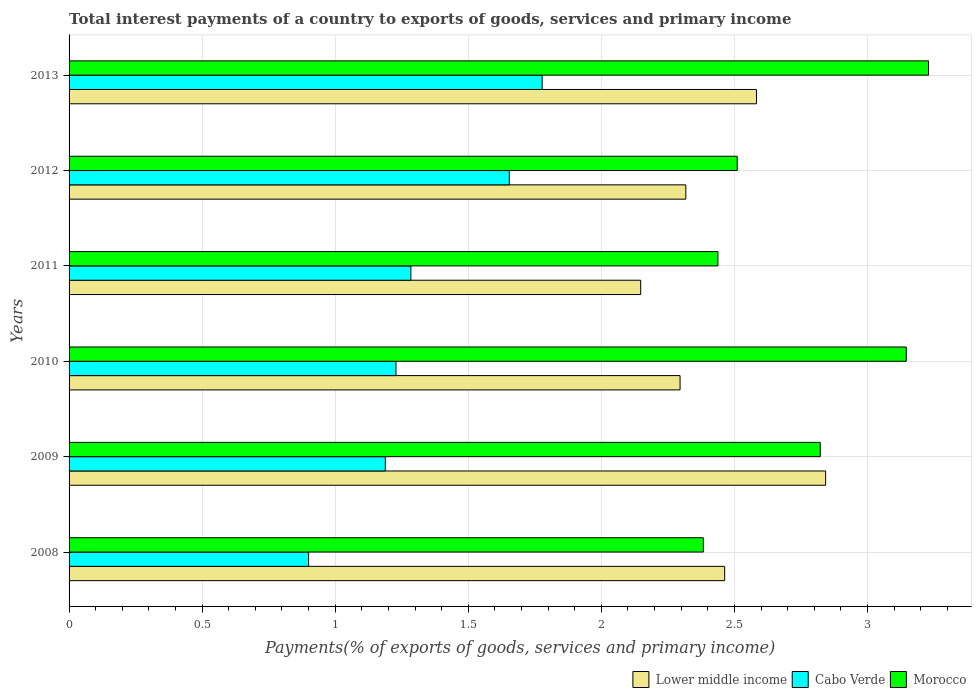Are the number of bars per tick equal to the number of legend labels?
Your response must be concise. Yes. How many bars are there on the 5th tick from the bottom?
Make the answer very short. 3. What is the total interest payments in Cabo Verde in 2011?
Keep it short and to the point. 1.28. Across all years, what is the maximum total interest payments in Cabo Verde?
Provide a short and direct response. 1.78. Across all years, what is the minimum total interest payments in Cabo Verde?
Offer a terse response. 0.9. In which year was the total interest payments in Morocco maximum?
Keep it short and to the point. 2013. In which year was the total interest payments in Cabo Verde minimum?
Make the answer very short. 2008. What is the total total interest payments in Lower middle income in the graph?
Your response must be concise. 14.65. What is the difference between the total interest payments in Cabo Verde in 2009 and that in 2012?
Offer a terse response. -0.47. What is the difference between the total interest payments in Morocco in 2009 and the total interest payments in Cabo Verde in 2012?
Provide a succinct answer. 1.17. What is the average total interest payments in Lower middle income per year?
Offer a very short reply. 2.44. In the year 2008, what is the difference between the total interest payments in Lower middle income and total interest payments in Cabo Verde?
Make the answer very short. 1.56. What is the ratio of the total interest payments in Cabo Verde in 2008 to that in 2012?
Provide a short and direct response. 0.54. What is the difference between the highest and the second highest total interest payments in Lower middle income?
Provide a succinct answer. 0.26. What is the difference between the highest and the lowest total interest payments in Morocco?
Your response must be concise. 0.85. Is the sum of the total interest payments in Lower middle income in 2009 and 2013 greater than the maximum total interest payments in Cabo Verde across all years?
Offer a very short reply. Yes. What does the 1st bar from the top in 2013 represents?
Give a very brief answer. Morocco. What does the 3rd bar from the bottom in 2008 represents?
Your answer should be compact. Morocco. Is it the case that in every year, the sum of the total interest payments in Lower middle income and total interest payments in Morocco is greater than the total interest payments in Cabo Verde?
Ensure brevity in your answer.  Yes. How many bars are there?
Provide a short and direct response. 18. Are all the bars in the graph horizontal?
Provide a succinct answer. Yes. Does the graph contain any zero values?
Your answer should be compact. No. Does the graph contain grids?
Offer a terse response. Yes. Where does the legend appear in the graph?
Provide a succinct answer. Bottom right. How are the legend labels stacked?
Keep it short and to the point. Horizontal. What is the title of the graph?
Your response must be concise. Total interest payments of a country to exports of goods, services and primary income. What is the label or title of the X-axis?
Offer a very short reply. Payments(% of exports of goods, services and primary income). What is the Payments(% of exports of goods, services and primary income) of Lower middle income in 2008?
Make the answer very short. 2.46. What is the Payments(% of exports of goods, services and primary income) of Cabo Verde in 2008?
Ensure brevity in your answer.  0.9. What is the Payments(% of exports of goods, services and primary income) of Morocco in 2008?
Provide a short and direct response. 2.38. What is the Payments(% of exports of goods, services and primary income) in Lower middle income in 2009?
Keep it short and to the point. 2.84. What is the Payments(% of exports of goods, services and primary income) in Cabo Verde in 2009?
Provide a short and direct response. 1.19. What is the Payments(% of exports of goods, services and primary income) in Morocco in 2009?
Offer a terse response. 2.82. What is the Payments(% of exports of goods, services and primary income) in Lower middle income in 2010?
Provide a succinct answer. 2.3. What is the Payments(% of exports of goods, services and primary income) of Cabo Verde in 2010?
Offer a terse response. 1.23. What is the Payments(% of exports of goods, services and primary income) of Morocco in 2010?
Your answer should be compact. 3.15. What is the Payments(% of exports of goods, services and primary income) in Lower middle income in 2011?
Offer a terse response. 2.15. What is the Payments(% of exports of goods, services and primary income) in Cabo Verde in 2011?
Provide a succinct answer. 1.28. What is the Payments(% of exports of goods, services and primary income) of Morocco in 2011?
Your response must be concise. 2.44. What is the Payments(% of exports of goods, services and primary income) in Lower middle income in 2012?
Provide a succinct answer. 2.32. What is the Payments(% of exports of goods, services and primary income) in Cabo Verde in 2012?
Provide a succinct answer. 1.65. What is the Payments(% of exports of goods, services and primary income) in Morocco in 2012?
Your answer should be very brief. 2.51. What is the Payments(% of exports of goods, services and primary income) in Lower middle income in 2013?
Give a very brief answer. 2.58. What is the Payments(% of exports of goods, services and primary income) in Cabo Verde in 2013?
Provide a succinct answer. 1.78. What is the Payments(% of exports of goods, services and primary income) of Morocco in 2013?
Provide a short and direct response. 3.23. Across all years, what is the maximum Payments(% of exports of goods, services and primary income) in Lower middle income?
Give a very brief answer. 2.84. Across all years, what is the maximum Payments(% of exports of goods, services and primary income) of Cabo Verde?
Ensure brevity in your answer.  1.78. Across all years, what is the maximum Payments(% of exports of goods, services and primary income) in Morocco?
Provide a succinct answer. 3.23. Across all years, what is the minimum Payments(% of exports of goods, services and primary income) of Lower middle income?
Offer a very short reply. 2.15. Across all years, what is the minimum Payments(% of exports of goods, services and primary income) of Cabo Verde?
Provide a succinct answer. 0.9. Across all years, what is the minimum Payments(% of exports of goods, services and primary income) of Morocco?
Give a very brief answer. 2.38. What is the total Payments(% of exports of goods, services and primary income) of Lower middle income in the graph?
Your answer should be very brief. 14.65. What is the total Payments(% of exports of goods, services and primary income) in Cabo Verde in the graph?
Your response must be concise. 8.03. What is the total Payments(% of exports of goods, services and primary income) in Morocco in the graph?
Your answer should be very brief. 16.53. What is the difference between the Payments(% of exports of goods, services and primary income) in Lower middle income in 2008 and that in 2009?
Keep it short and to the point. -0.38. What is the difference between the Payments(% of exports of goods, services and primary income) of Cabo Verde in 2008 and that in 2009?
Your response must be concise. -0.29. What is the difference between the Payments(% of exports of goods, services and primary income) of Morocco in 2008 and that in 2009?
Make the answer very short. -0.44. What is the difference between the Payments(% of exports of goods, services and primary income) in Lower middle income in 2008 and that in 2010?
Give a very brief answer. 0.17. What is the difference between the Payments(% of exports of goods, services and primary income) of Cabo Verde in 2008 and that in 2010?
Provide a short and direct response. -0.33. What is the difference between the Payments(% of exports of goods, services and primary income) in Morocco in 2008 and that in 2010?
Make the answer very short. -0.76. What is the difference between the Payments(% of exports of goods, services and primary income) in Lower middle income in 2008 and that in 2011?
Your response must be concise. 0.32. What is the difference between the Payments(% of exports of goods, services and primary income) of Cabo Verde in 2008 and that in 2011?
Offer a terse response. -0.38. What is the difference between the Payments(% of exports of goods, services and primary income) in Morocco in 2008 and that in 2011?
Ensure brevity in your answer.  -0.05. What is the difference between the Payments(% of exports of goods, services and primary income) in Lower middle income in 2008 and that in 2012?
Your response must be concise. 0.15. What is the difference between the Payments(% of exports of goods, services and primary income) in Cabo Verde in 2008 and that in 2012?
Ensure brevity in your answer.  -0.75. What is the difference between the Payments(% of exports of goods, services and primary income) of Morocco in 2008 and that in 2012?
Give a very brief answer. -0.13. What is the difference between the Payments(% of exports of goods, services and primary income) of Lower middle income in 2008 and that in 2013?
Offer a very short reply. -0.12. What is the difference between the Payments(% of exports of goods, services and primary income) in Cabo Verde in 2008 and that in 2013?
Keep it short and to the point. -0.88. What is the difference between the Payments(% of exports of goods, services and primary income) of Morocco in 2008 and that in 2013?
Offer a very short reply. -0.85. What is the difference between the Payments(% of exports of goods, services and primary income) in Lower middle income in 2009 and that in 2010?
Offer a terse response. 0.55. What is the difference between the Payments(% of exports of goods, services and primary income) in Cabo Verde in 2009 and that in 2010?
Your answer should be very brief. -0.04. What is the difference between the Payments(% of exports of goods, services and primary income) in Morocco in 2009 and that in 2010?
Provide a succinct answer. -0.32. What is the difference between the Payments(% of exports of goods, services and primary income) in Lower middle income in 2009 and that in 2011?
Provide a succinct answer. 0.69. What is the difference between the Payments(% of exports of goods, services and primary income) in Cabo Verde in 2009 and that in 2011?
Ensure brevity in your answer.  -0.1. What is the difference between the Payments(% of exports of goods, services and primary income) of Morocco in 2009 and that in 2011?
Your response must be concise. 0.38. What is the difference between the Payments(% of exports of goods, services and primary income) in Lower middle income in 2009 and that in 2012?
Your answer should be very brief. 0.53. What is the difference between the Payments(% of exports of goods, services and primary income) of Cabo Verde in 2009 and that in 2012?
Offer a very short reply. -0.47. What is the difference between the Payments(% of exports of goods, services and primary income) of Morocco in 2009 and that in 2012?
Make the answer very short. 0.31. What is the difference between the Payments(% of exports of goods, services and primary income) of Lower middle income in 2009 and that in 2013?
Provide a short and direct response. 0.26. What is the difference between the Payments(% of exports of goods, services and primary income) of Cabo Verde in 2009 and that in 2013?
Offer a very short reply. -0.59. What is the difference between the Payments(% of exports of goods, services and primary income) of Morocco in 2009 and that in 2013?
Your response must be concise. -0.41. What is the difference between the Payments(% of exports of goods, services and primary income) in Lower middle income in 2010 and that in 2011?
Keep it short and to the point. 0.15. What is the difference between the Payments(% of exports of goods, services and primary income) in Cabo Verde in 2010 and that in 2011?
Offer a very short reply. -0.06. What is the difference between the Payments(% of exports of goods, services and primary income) of Morocco in 2010 and that in 2011?
Your answer should be very brief. 0.71. What is the difference between the Payments(% of exports of goods, services and primary income) of Lower middle income in 2010 and that in 2012?
Offer a very short reply. -0.02. What is the difference between the Payments(% of exports of goods, services and primary income) of Cabo Verde in 2010 and that in 2012?
Offer a very short reply. -0.43. What is the difference between the Payments(% of exports of goods, services and primary income) of Morocco in 2010 and that in 2012?
Keep it short and to the point. 0.64. What is the difference between the Payments(% of exports of goods, services and primary income) of Lower middle income in 2010 and that in 2013?
Your response must be concise. -0.29. What is the difference between the Payments(% of exports of goods, services and primary income) in Cabo Verde in 2010 and that in 2013?
Offer a terse response. -0.55. What is the difference between the Payments(% of exports of goods, services and primary income) of Morocco in 2010 and that in 2013?
Give a very brief answer. -0.08. What is the difference between the Payments(% of exports of goods, services and primary income) of Lower middle income in 2011 and that in 2012?
Ensure brevity in your answer.  -0.17. What is the difference between the Payments(% of exports of goods, services and primary income) in Cabo Verde in 2011 and that in 2012?
Ensure brevity in your answer.  -0.37. What is the difference between the Payments(% of exports of goods, services and primary income) in Morocco in 2011 and that in 2012?
Offer a very short reply. -0.07. What is the difference between the Payments(% of exports of goods, services and primary income) of Lower middle income in 2011 and that in 2013?
Your response must be concise. -0.44. What is the difference between the Payments(% of exports of goods, services and primary income) in Cabo Verde in 2011 and that in 2013?
Make the answer very short. -0.49. What is the difference between the Payments(% of exports of goods, services and primary income) of Morocco in 2011 and that in 2013?
Make the answer very short. -0.79. What is the difference between the Payments(% of exports of goods, services and primary income) in Lower middle income in 2012 and that in 2013?
Offer a very short reply. -0.27. What is the difference between the Payments(% of exports of goods, services and primary income) in Cabo Verde in 2012 and that in 2013?
Provide a short and direct response. -0.12. What is the difference between the Payments(% of exports of goods, services and primary income) of Morocco in 2012 and that in 2013?
Provide a succinct answer. -0.72. What is the difference between the Payments(% of exports of goods, services and primary income) in Lower middle income in 2008 and the Payments(% of exports of goods, services and primary income) in Cabo Verde in 2009?
Ensure brevity in your answer.  1.28. What is the difference between the Payments(% of exports of goods, services and primary income) of Lower middle income in 2008 and the Payments(% of exports of goods, services and primary income) of Morocco in 2009?
Provide a succinct answer. -0.36. What is the difference between the Payments(% of exports of goods, services and primary income) in Cabo Verde in 2008 and the Payments(% of exports of goods, services and primary income) in Morocco in 2009?
Give a very brief answer. -1.92. What is the difference between the Payments(% of exports of goods, services and primary income) in Lower middle income in 2008 and the Payments(% of exports of goods, services and primary income) in Cabo Verde in 2010?
Your response must be concise. 1.24. What is the difference between the Payments(% of exports of goods, services and primary income) of Lower middle income in 2008 and the Payments(% of exports of goods, services and primary income) of Morocco in 2010?
Your response must be concise. -0.68. What is the difference between the Payments(% of exports of goods, services and primary income) of Cabo Verde in 2008 and the Payments(% of exports of goods, services and primary income) of Morocco in 2010?
Give a very brief answer. -2.25. What is the difference between the Payments(% of exports of goods, services and primary income) of Lower middle income in 2008 and the Payments(% of exports of goods, services and primary income) of Cabo Verde in 2011?
Offer a very short reply. 1.18. What is the difference between the Payments(% of exports of goods, services and primary income) of Lower middle income in 2008 and the Payments(% of exports of goods, services and primary income) of Morocco in 2011?
Your answer should be compact. 0.03. What is the difference between the Payments(% of exports of goods, services and primary income) of Cabo Verde in 2008 and the Payments(% of exports of goods, services and primary income) of Morocco in 2011?
Provide a short and direct response. -1.54. What is the difference between the Payments(% of exports of goods, services and primary income) in Lower middle income in 2008 and the Payments(% of exports of goods, services and primary income) in Cabo Verde in 2012?
Provide a succinct answer. 0.81. What is the difference between the Payments(% of exports of goods, services and primary income) in Lower middle income in 2008 and the Payments(% of exports of goods, services and primary income) in Morocco in 2012?
Ensure brevity in your answer.  -0.05. What is the difference between the Payments(% of exports of goods, services and primary income) of Cabo Verde in 2008 and the Payments(% of exports of goods, services and primary income) of Morocco in 2012?
Offer a very short reply. -1.61. What is the difference between the Payments(% of exports of goods, services and primary income) in Lower middle income in 2008 and the Payments(% of exports of goods, services and primary income) in Cabo Verde in 2013?
Your answer should be very brief. 0.69. What is the difference between the Payments(% of exports of goods, services and primary income) in Lower middle income in 2008 and the Payments(% of exports of goods, services and primary income) in Morocco in 2013?
Keep it short and to the point. -0.77. What is the difference between the Payments(% of exports of goods, services and primary income) of Cabo Verde in 2008 and the Payments(% of exports of goods, services and primary income) of Morocco in 2013?
Your answer should be very brief. -2.33. What is the difference between the Payments(% of exports of goods, services and primary income) in Lower middle income in 2009 and the Payments(% of exports of goods, services and primary income) in Cabo Verde in 2010?
Ensure brevity in your answer.  1.61. What is the difference between the Payments(% of exports of goods, services and primary income) of Lower middle income in 2009 and the Payments(% of exports of goods, services and primary income) of Morocco in 2010?
Make the answer very short. -0.3. What is the difference between the Payments(% of exports of goods, services and primary income) of Cabo Verde in 2009 and the Payments(% of exports of goods, services and primary income) of Morocco in 2010?
Your response must be concise. -1.96. What is the difference between the Payments(% of exports of goods, services and primary income) in Lower middle income in 2009 and the Payments(% of exports of goods, services and primary income) in Cabo Verde in 2011?
Provide a succinct answer. 1.56. What is the difference between the Payments(% of exports of goods, services and primary income) of Lower middle income in 2009 and the Payments(% of exports of goods, services and primary income) of Morocco in 2011?
Your response must be concise. 0.4. What is the difference between the Payments(% of exports of goods, services and primary income) in Cabo Verde in 2009 and the Payments(% of exports of goods, services and primary income) in Morocco in 2011?
Your answer should be very brief. -1.25. What is the difference between the Payments(% of exports of goods, services and primary income) in Lower middle income in 2009 and the Payments(% of exports of goods, services and primary income) in Cabo Verde in 2012?
Ensure brevity in your answer.  1.19. What is the difference between the Payments(% of exports of goods, services and primary income) of Lower middle income in 2009 and the Payments(% of exports of goods, services and primary income) of Morocco in 2012?
Your answer should be compact. 0.33. What is the difference between the Payments(% of exports of goods, services and primary income) in Cabo Verde in 2009 and the Payments(% of exports of goods, services and primary income) in Morocco in 2012?
Give a very brief answer. -1.32. What is the difference between the Payments(% of exports of goods, services and primary income) of Lower middle income in 2009 and the Payments(% of exports of goods, services and primary income) of Cabo Verde in 2013?
Provide a short and direct response. 1.07. What is the difference between the Payments(% of exports of goods, services and primary income) in Lower middle income in 2009 and the Payments(% of exports of goods, services and primary income) in Morocco in 2013?
Your answer should be very brief. -0.39. What is the difference between the Payments(% of exports of goods, services and primary income) of Cabo Verde in 2009 and the Payments(% of exports of goods, services and primary income) of Morocco in 2013?
Make the answer very short. -2.04. What is the difference between the Payments(% of exports of goods, services and primary income) of Lower middle income in 2010 and the Payments(% of exports of goods, services and primary income) of Cabo Verde in 2011?
Keep it short and to the point. 1.01. What is the difference between the Payments(% of exports of goods, services and primary income) in Lower middle income in 2010 and the Payments(% of exports of goods, services and primary income) in Morocco in 2011?
Your answer should be very brief. -0.14. What is the difference between the Payments(% of exports of goods, services and primary income) in Cabo Verde in 2010 and the Payments(% of exports of goods, services and primary income) in Morocco in 2011?
Keep it short and to the point. -1.21. What is the difference between the Payments(% of exports of goods, services and primary income) of Lower middle income in 2010 and the Payments(% of exports of goods, services and primary income) of Cabo Verde in 2012?
Ensure brevity in your answer.  0.64. What is the difference between the Payments(% of exports of goods, services and primary income) in Lower middle income in 2010 and the Payments(% of exports of goods, services and primary income) in Morocco in 2012?
Your response must be concise. -0.21. What is the difference between the Payments(% of exports of goods, services and primary income) of Cabo Verde in 2010 and the Payments(% of exports of goods, services and primary income) of Morocco in 2012?
Provide a succinct answer. -1.28. What is the difference between the Payments(% of exports of goods, services and primary income) of Lower middle income in 2010 and the Payments(% of exports of goods, services and primary income) of Cabo Verde in 2013?
Provide a short and direct response. 0.52. What is the difference between the Payments(% of exports of goods, services and primary income) of Lower middle income in 2010 and the Payments(% of exports of goods, services and primary income) of Morocco in 2013?
Ensure brevity in your answer.  -0.93. What is the difference between the Payments(% of exports of goods, services and primary income) in Cabo Verde in 2010 and the Payments(% of exports of goods, services and primary income) in Morocco in 2013?
Make the answer very short. -2. What is the difference between the Payments(% of exports of goods, services and primary income) of Lower middle income in 2011 and the Payments(% of exports of goods, services and primary income) of Cabo Verde in 2012?
Provide a succinct answer. 0.49. What is the difference between the Payments(% of exports of goods, services and primary income) in Lower middle income in 2011 and the Payments(% of exports of goods, services and primary income) in Morocco in 2012?
Give a very brief answer. -0.36. What is the difference between the Payments(% of exports of goods, services and primary income) in Cabo Verde in 2011 and the Payments(% of exports of goods, services and primary income) in Morocco in 2012?
Provide a short and direct response. -1.23. What is the difference between the Payments(% of exports of goods, services and primary income) of Lower middle income in 2011 and the Payments(% of exports of goods, services and primary income) of Cabo Verde in 2013?
Keep it short and to the point. 0.37. What is the difference between the Payments(% of exports of goods, services and primary income) in Lower middle income in 2011 and the Payments(% of exports of goods, services and primary income) in Morocco in 2013?
Provide a short and direct response. -1.08. What is the difference between the Payments(% of exports of goods, services and primary income) in Cabo Verde in 2011 and the Payments(% of exports of goods, services and primary income) in Morocco in 2013?
Your answer should be very brief. -1.95. What is the difference between the Payments(% of exports of goods, services and primary income) in Lower middle income in 2012 and the Payments(% of exports of goods, services and primary income) in Cabo Verde in 2013?
Offer a very short reply. 0.54. What is the difference between the Payments(% of exports of goods, services and primary income) in Lower middle income in 2012 and the Payments(% of exports of goods, services and primary income) in Morocco in 2013?
Your answer should be compact. -0.91. What is the difference between the Payments(% of exports of goods, services and primary income) in Cabo Verde in 2012 and the Payments(% of exports of goods, services and primary income) in Morocco in 2013?
Your answer should be compact. -1.58. What is the average Payments(% of exports of goods, services and primary income) of Lower middle income per year?
Your response must be concise. 2.44. What is the average Payments(% of exports of goods, services and primary income) of Cabo Verde per year?
Your answer should be compact. 1.34. What is the average Payments(% of exports of goods, services and primary income) of Morocco per year?
Your answer should be very brief. 2.75. In the year 2008, what is the difference between the Payments(% of exports of goods, services and primary income) of Lower middle income and Payments(% of exports of goods, services and primary income) of Cabo Verde?
Provide a succinct answer. 1.56. In the year 2008, what is the difference between the Payments(% of exports of goods, services and primary income) of Lower middle income and Payments(% of exports of goods, services and primary income) of Morocco?
Give a very brief answer. 0.08. In the year 2008, what is the difference between the Payments(% of exports of goods, services and primary income) of Cabo Verde and Payments(% of exports of goods, services and primary income) of Morocco?
Your response must be concise. -1.48. In the year 2009, what is the difference between the Payments(% of exports of goods, services and primary income) in Lower middle income and Payments(% of exports of goods, services and primary income) in Cabo Verde?
Offer a very short reply. 1.65. In the year 2009, what is the difference between the Payments(% of exports of goods, services and primary income) in Lower middle income and Payments(% of exports of goods, services and primary income) in Morocco?
Your response must be concise. 0.02. In the year 2009, what is the difference between the Payments(% of exports of goods, services and primary income) of Cabo Verde and Payments(% of exports of goods, services and primary income) of Morocco?
Ensure brevity in your answer.  -1.63. In the year 2010, what is the difference between the Payments(% of exports of goods, services and primary income) of Lower middle income and Payments(% of exports of goods, services and primary income) of Cabo Verde?
Provide a succinct answer. 1.07. In the year 2010, what is the difference between the Payments(% of exports of goods, services and primary income) in Lower middle income and Payments(% of exports of goods, services and primary income) in Morocco?
Make the answer very short. -0.85. In the year 2010, what is the difference between the Payments(% of exports of goods, services and primary income) in Cabo Verde and Payments(% of exports of goods, services and primary income) in Morocco?
Your response must be concise. -1.92. In the year 2011, what is the difference between the Payments(% of exports of goods, services and primary income) in Lower middle income and Payments(% of exports of goods, services and primary income) in Cabo Verde?
Your answer should be very brief. 0.86. In the year 2011, what is the difference between the Payments(% of exports of goods, services and primary income) of Lower middle income and Payments(% of exports of goods, services and primary income) of Morocco?
Ensure brevity in your answer.  -0.29. In the year 2011, what is the difference between the Payments(% of exports of goods, services and primary income) of Cabo Verde and Payments(% of exports of goods, services and primary income) of Morocco?
Ensure brevity in your answer.  -1.15. In the year 2012, what is the difference between the Payments(% of exports of goods, services and primary income) in Lower middle income and Payments(% of exports of goods, services and primary income) in Cabo Verde?
Make the answer very short. 0.66. In the year 2012, what is the difference between the Payments(% of exports of goods, services and primary income) in Lower middle income and Payments(% of exports of goods, services and primary income) in Morocco?
Your answer should be very brief. -0.19. In the year 2012, what is the difference between the Payments(% of exports of goods, services and primary income) in Cabo Verde and Payments(% of exports of goods, services and primary income) in Morocco?
Ensure brevity in your answer.  -0.86. In the year 2013, what is the difference between the Payments(% of exports of goods, services and primary income) of Lower middle income and Payments(% of exports of goods, services and primary income) of Cabo Verde?
Provide a succinct answer. 0.81. In the year 2013, what is the difference between the Payments(% of exports of goods, services and primary income) in Lower middle income and Payments(% of exports of goods, services and primary income) in Morocco?
Provide a succinct answer. -0.65. In the year 2013, what is the difference between the Payments(% of exports of goods, services and primary income) of Cabo Verde and Payments(% of exports of goods, services and primary income) of Morocco?
Offer a terse response. -1.45. What is the ratio of the Payments(% of exports of goods, services and primary income) of Lower middle income in 2008 to that in 2009?
Ensure brevity in your answer.  0.87. What is the ratio of the Payments(% of exports of goods, services and primary income) of Cabo Verde in 2008 to that in 2009?
Your answer should be very brief. 0.76. What is the ratio of the Payments(% of exports of goods, services and primary income) in Morocco in 2008 to that in 2009?
Give a very brief answer. 0.84. What is the ratio of the Payments(% of exports of goods, services and primary income) of Lower middle income in 2008 to that in 2010?
Your response must be concise. 1.07. What is the ratio of the Payments(% of exports of goods, services and primary income) in Cabo Verde in 2008 to that in 2010?
Your answer should be very brief. 0.73. What is the ratio of the Payments(% of exports of goods, services and primary income) in Morocco in 2008 to that in 2010?
Offer a terse response. 0.76. What is the ratio of the Payments(% of exports of goods, services and primary income) in Lower middle income in 2008 to that in 2011?
Offer a terse response. 1.15. What is the ratio of the Payments(% of exports of goods, services and primary income) in Cabo Verde in 2008 to that in 2011?
Provide a succinct answer. 0.7. What is the ratio of the Payments(% of exports of goods, services and primary income) in Morocco in 2008 to that in 2011?
Provide a short and direct response. 0.98. What is the ratio of the Payments(% of exports of goods, services and primary income) of Lower middle income in 2008 to that in 2012?
Offer a terse response. 1.06. What is the ratio of the Payments(% of exports of goods, services and primary income) of Cabo Verde in 2008 to that in 2012?
Provide a succinct answer. 0.54. What is the ratio of the Payments(% of exports of goods, services and primary income) in Morocco in 2008 to that in 2012?
Provide a short and direct response. 0.95. What is the ratio of the Payments(% of exports of goods, services and primary income) in Lower middle income in 2008 to that in 2013?
Give a very brief answer. 0.95. What is the ratio of the Payments(% of exports of goods, services and primary income) of Cabo Verde in 2008 to that in 2013?
Offer a terse response. 0.51. What is the ratio of the Payments(% of exports of goods, services and primary income) of Morocco in 2008 to that in 2013?
Provide a short and direct response. 0.74. What is the ratio of the Payments(% of exports of goods, services and primary income) in Lower middle income in 2009 to that in 2010?
Provide a succinct answer. 1.24. What is the ratio of the Payments(% of exports of goods, services and primary income) in Cabo Verde in 2009 to that in 2010?
Offer a very short reply. 0.97. What is the ratio of the Payments(% of exports of goods, services and primary income) of Morocco in 2009 to that in 2010?
Offer a terse response. 0.9. What is the ratio of the Payments(% of exports of goods, services and primary income) of Lower middle income in 2009 to that in 2011?
Keep it short and to the point. 1.32. What is the ratio of the Payments(% of exports of goods, services and primary income) of Cabo Verde in 2009 to that in 2011?
Give a very brief answer. 0.93. What is the ratio of the Payments(% of exports of goods, services and primary income) of Morocco in 2009 to that in 2011?
Offer a very short reply. 1.16. What is the ratio of the Payments(% of exports of goods, services and primary income) in Lower middle income in 2009 to that in 2012?
Provide a succinct answer. 1.23. What is the ratio of the Payments(% of exports of goods, services and primary income) of Cabo Verde in 2009 to that in 2012?
Your answer should be compact. 0.72. What is the ratio of the Payments(% of exports of goods, services and primary income) in Morocco in 2009 to that in 2012?
Offer a very short reply. 1.12. What is the ratio of the Payments(% of exports of goods, services and primary income) in Lower middle income in 2009 to that in 2013?
Your answer should be compact. 1.1. What is the ratio of the Payments(% of exports of goods, services and primary income) of Cabo Verde in 2009 to that in 2013?
Your response must be concise. 0.67. What is the ratio of the Payments(% of exports of goods, services and primary income) of Morocco in 2009 to that in 2013?
Make the answer very short. 0.87. What is the ratio of the Payments(% of exports of goods, services and primary income) of Lower middle income in 2010 to that in 2011?
Keep it short and to the point. 1.07. What is the ratio of the Payments(% of exports of goods, services and primary income) in Cabo Verde in 2010 to that in 2011?
Make the answer very short. 0.96. What is the ratio of the Payments(% of exports of goods, services and primary income) of Morocco in 2010 to that in 2011?
Make the answer very short. 1.29. What is the ratio of the Payments(% of exports of goods, services and primary income) of Cabo Verde in 2010 to that in 2012?
Make the answer very short. 0.74. What is the ratio of the Payments(% of exports of goods, services and primary income) in Morocco in 2010 to that in 2012?
Your response must be concise. 1.25. What is the ratio of the Payments(% of exports of goods, services and primary income) of Lower middle income in 2010 to that in 2013?
Provide a short and direct response. 0.89. What is the ratio of the Payments(% of exports of goods, services and primary income) in Cabo Verde in 2010 to that in 2013?
Your response must be concise. 0.69. What is the ratio of the Payments(% of exports of goods, services and primary income) of Morocco in 2010 to that in 2013?
Ensure brevity in your answer.  0.97. What is the ratio of the Payments(% of exports of goods, services and primary income) in Lower middle income in 2011 to that in 2012?
Offer a very short reply. 0.93. What is the ratio of the Payments(% of exports of goods, services and primary income) in Cabo Verde in 2011 to that in 2012?
Offer a terse response. 0.78. What is the ratio of the Payments(% of exports of goods, services and primary income) in Morocco in 2011 to that in 2012?
Your response must be concise. 0.97. What is the ratio of the Payments(% of exports of goods, services and primary income) in Lower middle income in 2011 to that in 2013?
Provide a succinct answer. 0.83. What is the ratio of the Payments(% of exports of goods, services and primary income) in Cabo Verde in 2011 to that in 2013?
Provide a succinct answer. 0.72. What is the ratio of the Payments(% of exports of goods, services and primary income) in Morocco in 2011 to that in 2013?
Give a very brief answer. 0.76. What is the ratio of the Payments(% of exports of goods, services and primary income) in Lower middle income in 2012 to that in 2013?
Offer a terse response. 0.9. What is the ratio of the Payments(% of exports of goods, services and primary income) in Cabo Verde in 2012 to that in 2013?
Offer a very short reply. 0.93. What is the ratio of the Payments(% of exports of goods, services and primary income) in Morocco in 2012 to that in 2013?
Keep it short and to the point. 0.78. What is the difference between the highest and the second highest Payments(% of exports of goods, services and primary income) of Lower middle income?
Your answer should be compact. 0.26. What is the difference between the highest and the second highest Payments(% of exports of goods, services and primary income) in Cabo Verde?
Your answer should be very brief. 0.12. What is the difference between the highest and the second highest Payments(% of exports of goods, services and primary income) of Morocco?
Ensure brevity in your answer.  0.08. What is the difference between the highest and the lowest Payments(% of exports of goods, services and primary income) in Lower middle income?
Keep it short and to the point. 0.69. What is the difference between the highest and the lowest Payments(% of exports of goods, services and primary income) in Cabo Verde?
Your answer should be very brief. 0.88. What is the difference between the highest and the lowest Payments(% of exports of goods, services and primary income) of Morocco?
Your answer should be very brief. 0.85. 